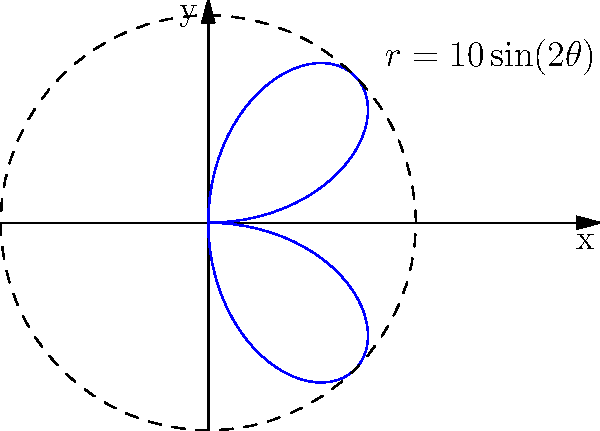In a theatrical production, a prop is thrown across the stage following a trajectory described by the polar equation $r=10\sin(2\theta)$, where $r$ is in meters. What is the maximum distance, in meters, that the prop travels from the point of release? To find the maximum distance the prop travels from the point of release, we need to determine the maximum value of $r$ in the given polar equation.

Step 1: Analyze the equation $r=10\sin(2\theta)$
- The amplitude of the sine function is 10.
- The sine function oscillates between -1 and 1.

Step 2: Determine the maximum value of $r$
- The maximum value of $\sin(2\theta)$ is 1.
- Therefore, the maximum value of $r$ is $10 \cdot 1 = 10$.

Step 3: Interpret the result
- The maximum distance occurs when $r$ is at its maximum value.
- This maximum distance is 10 meters from the point of release.

Note: The graph shows a four-leaf rose pattern, with each leaf extending 10 meters from the origin. This represents the various positions the prop can take during its trajectory, with the furthest points being 10 meters away.
Answer: 10 meters 